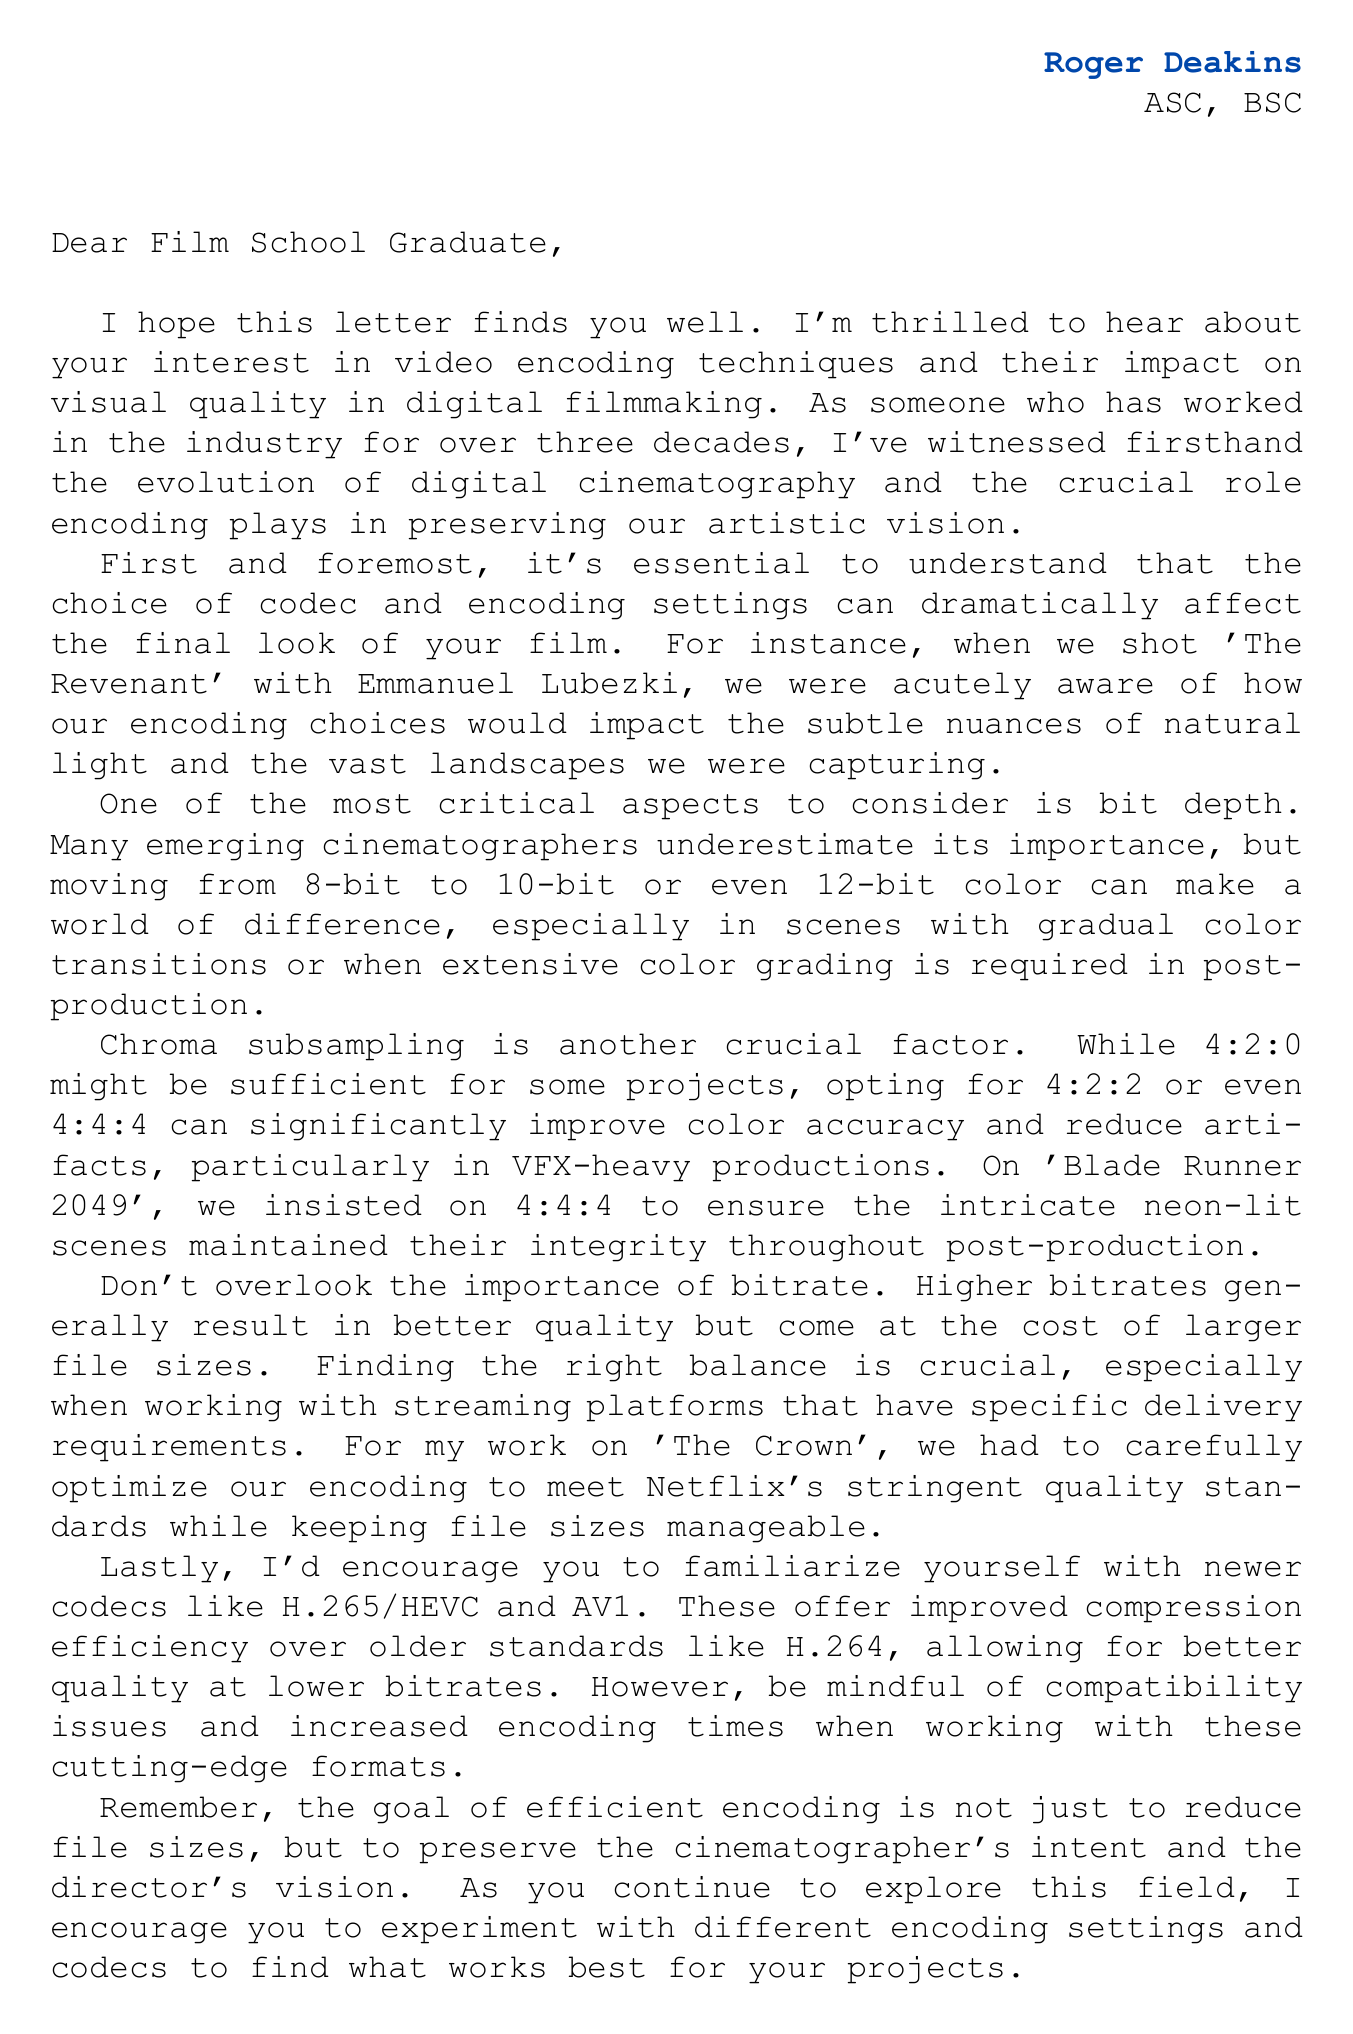What is the name of the cinematographer who wrote the letter? The letter is signed by Roger Deakins, indicating authorship.
Answer: Roger Deakins What is the primary subject of the letter? The letter discusses video encoding techniques and their impact on visual quality in digital filmmaking.
Answer: Video encoding Which notable work is mentioned in relation to bit depth? The letter cites the importance of bit depth in color transitions and references the film 'The Revenant'.
Answer: The Revenant What chroma subsampling method was used in 'Blade Runner 2049'? The letter mentions that a specific chroma subsampling method was chosen to preserve color integrity.
Answer: 4:4:4 Name one newer codec recommended in the letter. The letter advises familiarity with newer codecs, naming H.265/HEVC as an example.
Answer: H.265/HEVC What is one critical aspect of encoding discussed in relation to file sizes? The letter addresses the balance between quality and file sizes, particularly the importance of bitrate.
Answer: Bitrate What does the cinematographer urge readers to do regarding encoding settings? The conclusion encourages experimentation with different encoding settings for projects.
Answer: Experiment with settings What organizations are mentioned as relevant in the context of the letter? The letter lists organizations associated with cinematography, including the American Society of Cinematographers (ASC).
Answer: ASC In which film did the cinematographer insist on using 4:4:4 subsampling? The discussion surrounding chroma subsampling includes a specific film where this method was crucial.
Answer: Blade Runner 2049 